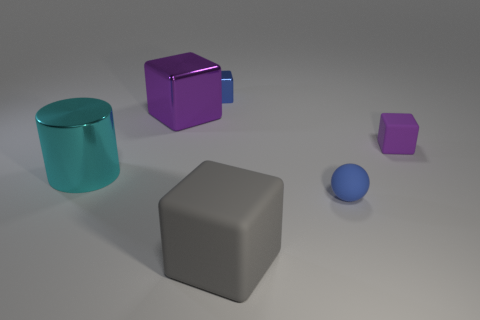The blue object to the right of the big object in front of the tiny blue thing in front of the large cyan metal cylinder is what shape?
Your response must be concise. Sphere. Is there anything else that is the same shape as the big cyan metal object?
Make the answer very short. No. How many blocks are purple objects or cyan metal things?
Make the answer very short. 2. Does the metal cube left of the blue metal block have the same color as the tiny rubber block?
Make the answer very short. Yes. The small block on the left side of the rubber thing that is on the left side of the blue thing in front of the blue shiny cube is made of what material?
Offer a terse response. Metal. Do the matte sphere and the blue metal cube have the same size?
Offer a terse response. Yes. Does the tiny rubber sphere have the same color as the small block on the left side of the small blue matte ball?
Offer a terse response. Yes. There is a big cyan thing that is the same material as the blue cube; what shape is it?
Keep it short and to the point. Cylinder. There is a small blue object that is on the left side of the small sphere; does it have the same shape as the small purple rubber object?
Your answer should be compact. Yes. What size is the purple cube left of the large block that is to the right of the blue cube?
Your answer should be compact. Large. 